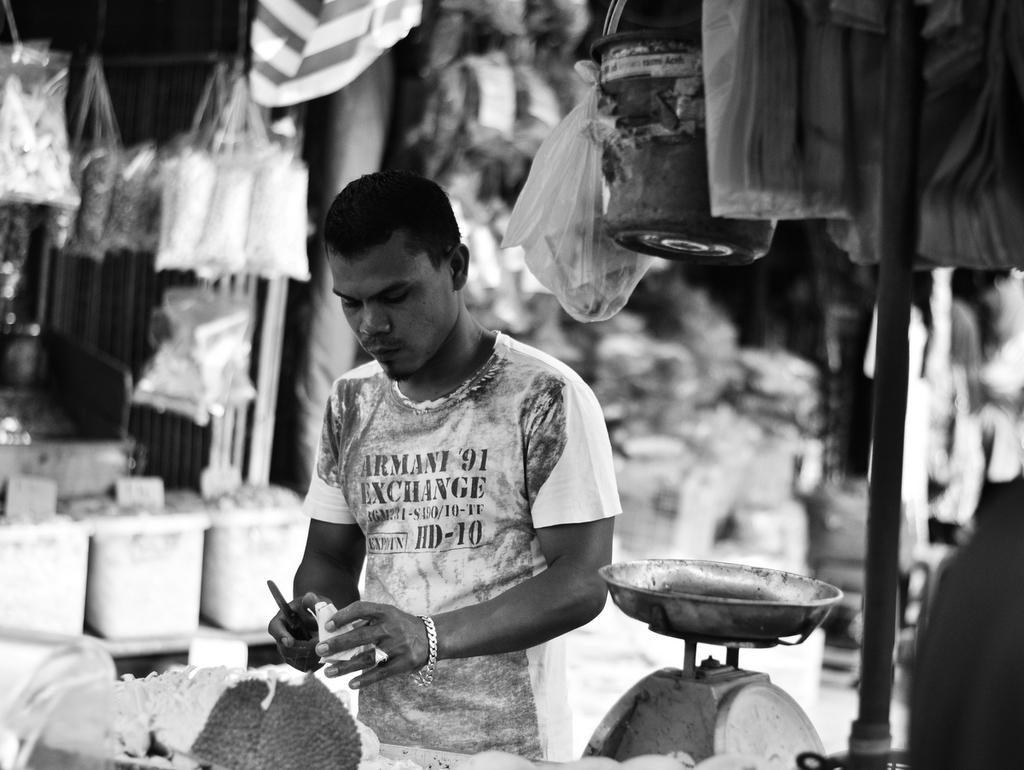What is the color scheme of the image? The image is black and white. Who is the main subject in the image? There is a man in the middle of the image. What is the man doing in the image? The man is cutting a fruit. What can be seen on the right side of the image? There is a weighing machine on the right side of the image. What is visible in the background of the image? There are stores visible in the background of the image. What type of oil is being used by the man to cut the fruit in the image? There is no oil present in the image; the man is simply cutting a fruit with a knife. How does the man's stomach look while cutting the fruit in the image? The image does not show the man's stomach, so it cannot be described. 